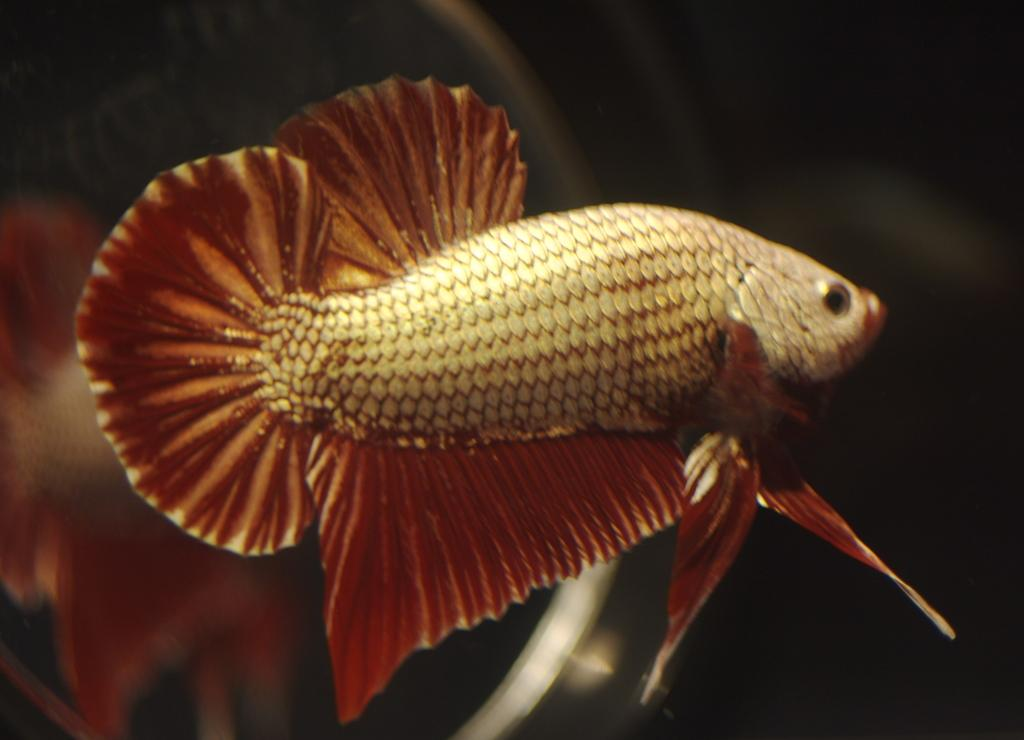What type of animals can be seen in the image? There are fish in the image. Can you describe the background of the image? The background of the image is blurred. How many rabbits can be seen in the image? There are no rabbits present in the image; it features fish. What type of ocean is visible in the image? There is no ocean visible in the image; it features fish in an unspecified setting. 